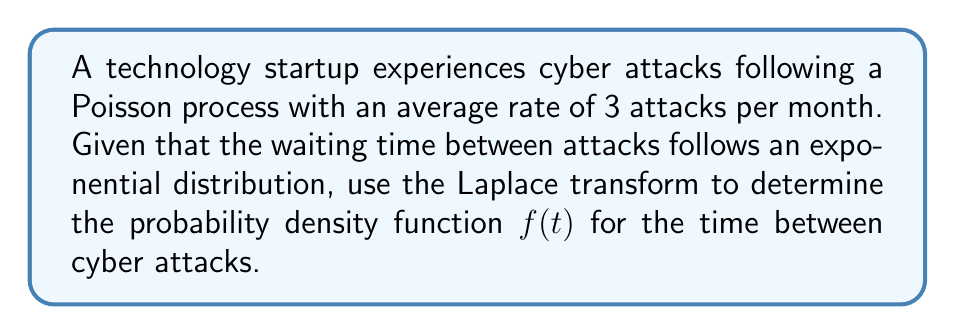Solve this math problem. Let's approach this step-by-step:

1) For a Poisson process with rate $\lambda$, the waiting time between events follows an exponential distribution with parameter $\lambda$. Here, $\lambda = 3$ attacks/month.

2) The general form of the Laplace transform of a function $f(t)$ is:

   $$F(s) = \mathcal{L}\{f(t)\} = \int_0^\infty e^{-st}f(t)dt$$

3) For an exponential distribution with parameter $\lambda$, the Laplace transform is:

   $$F(s) = \frac{\lambda}{s + \lambda}$$

4) In our case, $\lambda = 3$, so:

   $$F(s) = \frac{3}{s + 3}$$

5) To find $f(t)$, we need to take the inverse Laplace transform of $F(s)$:

   $$f(t) = \mathcal{L}^{-1}\{F(s)\} = \mathcal{L}^{-1}\left\{\frac{3}{s + 3}\right\}$$

6) The inverse Laplace transform of $\frac{a}{s + a}$ is $ae^{-at}$. Therefore:

   $$f(t) = 3e^{-3t}$$

7) This is indeed the probability density function of an exponential distribution with parameter $\lambda = 3$.
Answer: $f(t) = 3e^{-3t}$ 